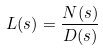<formula> <loc_0><loc_0><loc_500><loc_500>L ( s ) = \frac { N ( s ) } { D ( s ) }</formula> 